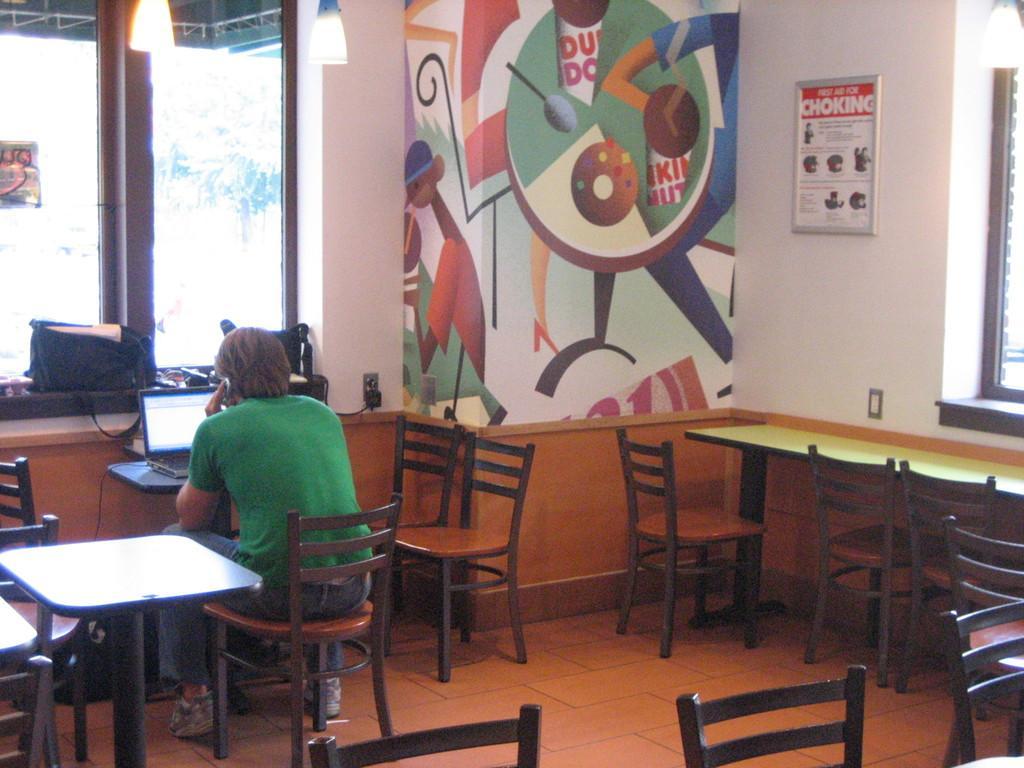Describe this image in one or two sentences. In this picture we can see man sitting on chair and talking on phone and in front of him we can see laptop on table, bag on window and at back of him we can see tables, chairs, wall with frames. 